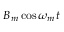Convert formula to latex. <formula><loc_0><loc_0><loc_500><loc_500>B _ { m } \cos \omega _ { m } t</formula> 